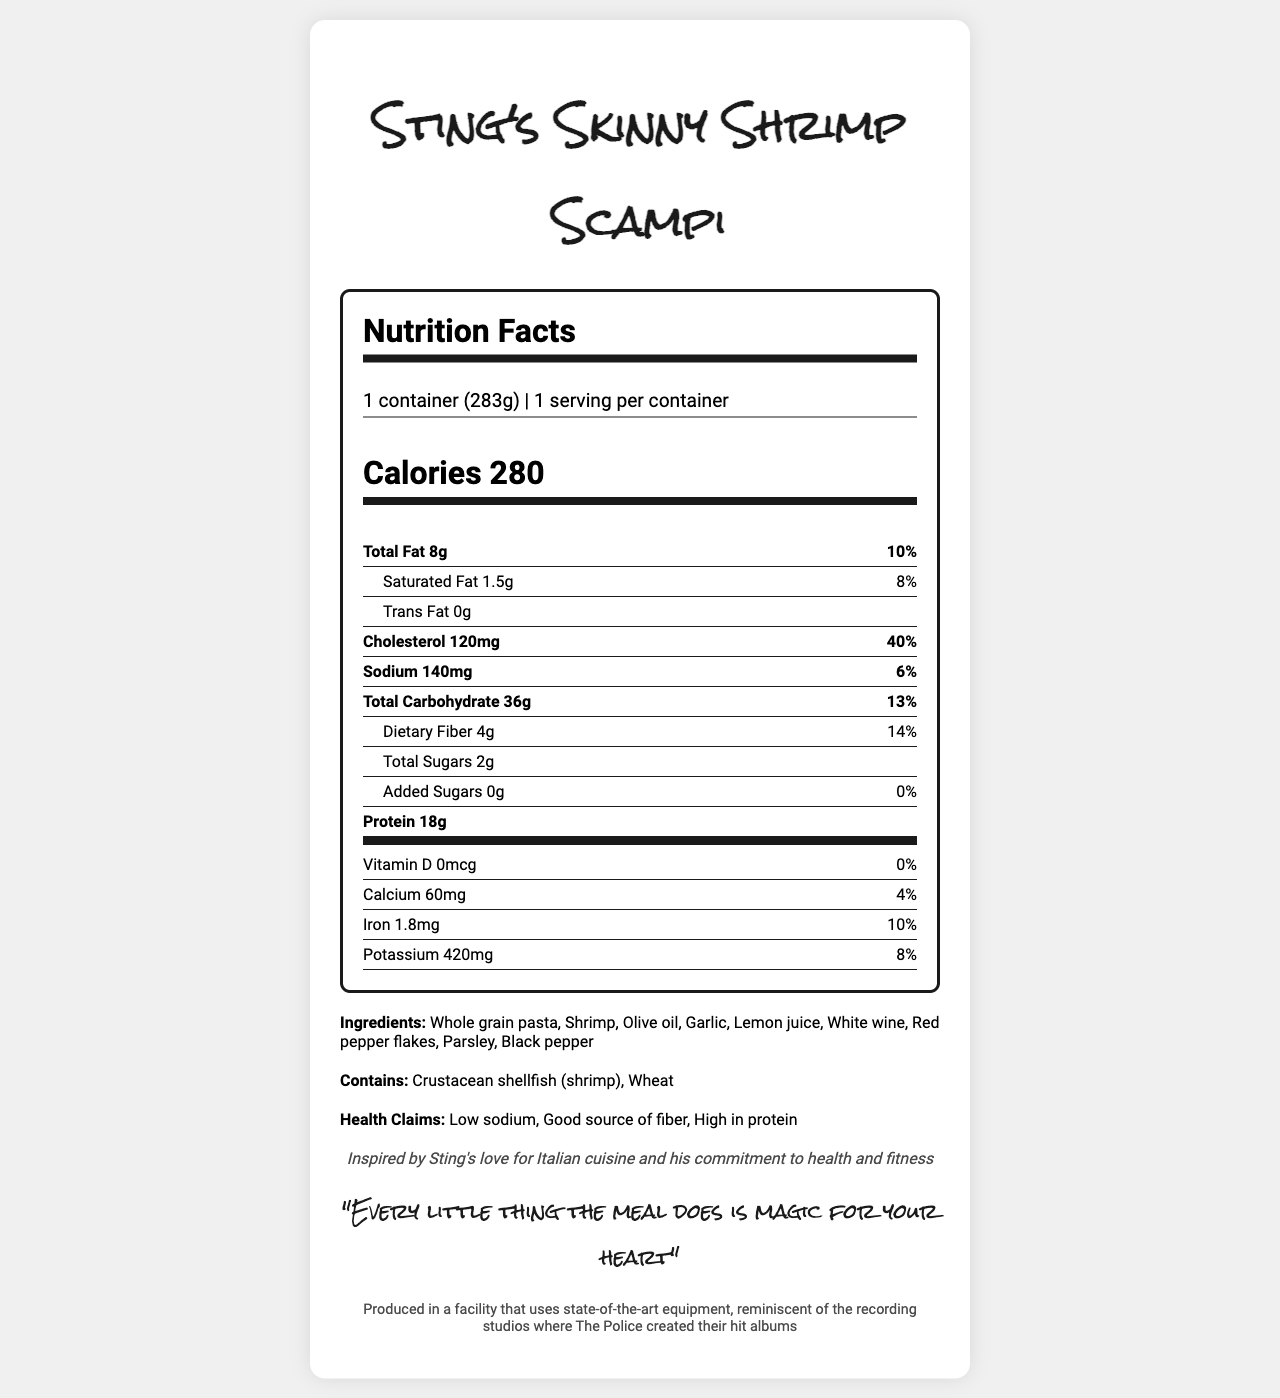what is the serving size for Sting's Skinny Shrimp Scampi? The serving size is clearly stated at the top of the Nutrition Facts section as "1 container (283g)".
Answer: 1 container (283g) how many calories does one serving contain? The calories per serving are listed immediately after the serving size as "Calories 280".
Answer: 280 what percentage of the daily value of sodium does this meal provide? The sodium content and its daily value percentage are provided in the nutrient section, showing "Sodium 140mg" and "6%" respectively.
Answer: 6% which ingredient is used as the main source of protein in this meal? The ingredients list includes "Shrimp" which is a well-known high-protein food.
Answer: Shrimp what are the allergens listed for this product? The document lists allergens specifically under the "Contains:" section as "Crustacean shellfish (shrimp), Wheat".
Answer: Crustacean shellfish (shrimp), Wheat which of the following best describes the inspiration behind this meal? A. Inspired by a famous concert B. Inspired by Sting's Italian cuisine preference C. Inspired by traditional British dishes The document mentions "Inspired by Sting's love for Italian cuisine and his commitment to health and fitness".
Answer: B what is the total amount of fat in this meal? The total amount of fat is listed in the nutrient section as "Total Fat 8g".
Answer: 8g does this meal contain any added sugars? The nutrient section shows "Added Sugars 0g" and "0%", indicating there are no added sugars in the meal.
Answer: No how much dietary fiber does one serving provide? The dietary fiber amount is listed under total carbohydrates as "Dietary Fiber 4g".
Answer: 4g which nutrient is present in the smallest amount by weight? A. Iron B. Vitamin D C. Trans Fat Vitamin D is present in the smallest amount by weight at 0mcg.
Answer: B what is the total amount of protein in this meal? The protein content is displayed prominently in the nutrient section as "Protein 18g".
Answer: 18g is this meal considered high in sodium? The sodium is listed as 140mg, which is only 6% of the daily value, thereby classifying it as low sodium.
Answer: No summarize the main health benefits of Sting's Skinny Shrimp Scampi. The meal is advertised with health claims such as "Low sodium", "Good source of fiber", and "High in protein".
Answer: Low in sodium, high in protein, good source of fiber in what facility condition is this meal produced? The document includes a production note stating this condition.
Answer: Produced in a facility that uses state-of-the-art equipment, reminiscent of the recording studios where The Police created their hit albums how much calcium does this meal provide? The calcium content is found in the vitamins section as "Calcium 60mg".
Answer: 60mg how long does it take to prepare this frozen meal? The document does not mention the preparation time for the meal.
Answer: Not enough information 